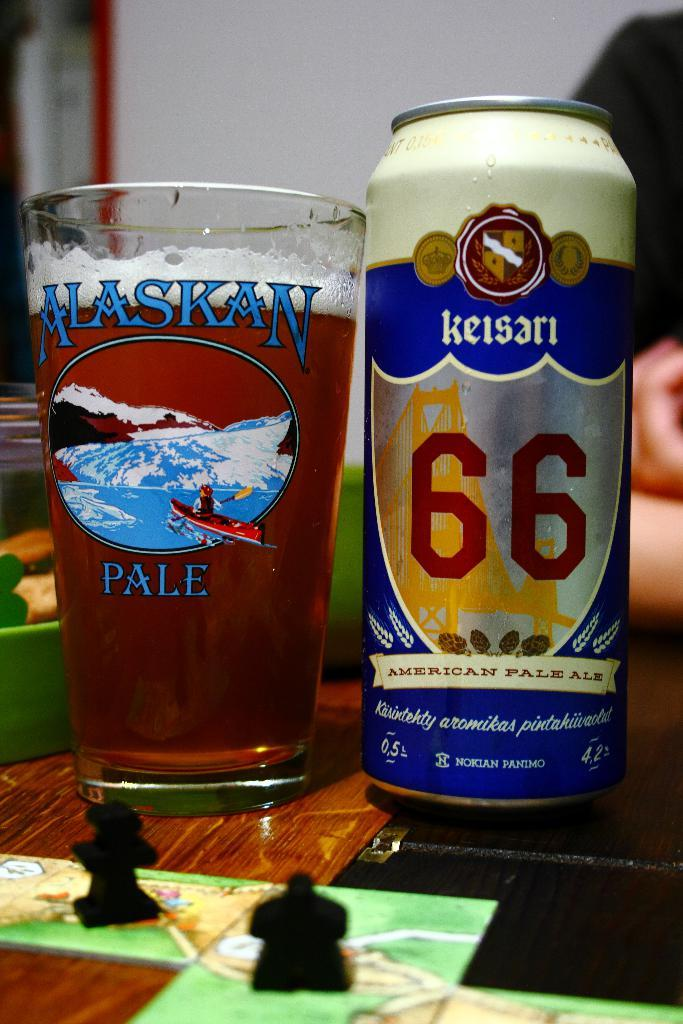<image>
Describe the image concisely. A can of Keisari pale ale is next to a full glass. 